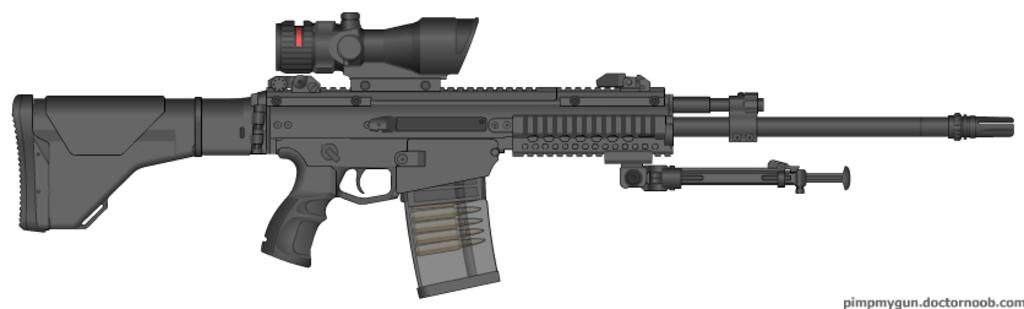What is the main object in the foreground of the image? There is a depicted gun in the foreground of the image. What color is the background of the image? The background of the image is white. How many flowers are present in the image? There are no flowers visible in the image. What type of balloon can be seen in the image? There are no balloons present in the image. 